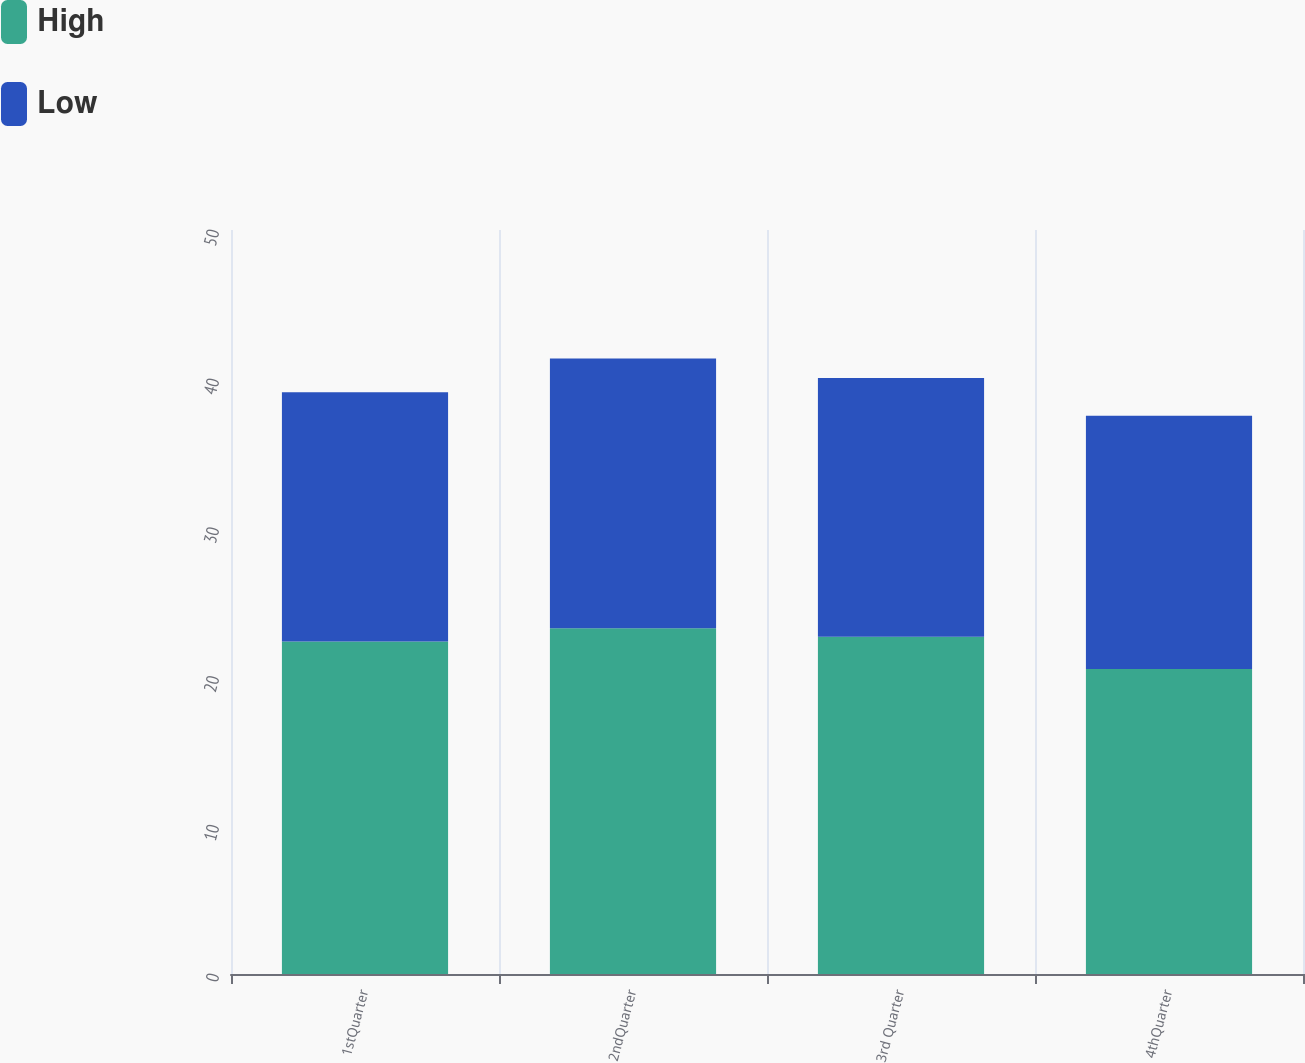<chart> <loc_0><loc_0><loc_500><loc_500><stacked_bar_chart><ecel><fcel>1stQuarter<fcel>2ndQuarter<fcel>3rd Quarter<fcel>4thQuarter<nl><fcel>High<fcel>22.35<fcel>23.23<fcel>22.66<fcel>20.5<nl><fcel>Low<fcel>16.75<fcel>18.13<fcel>17.39<fcel>17.01<nl></chart> 